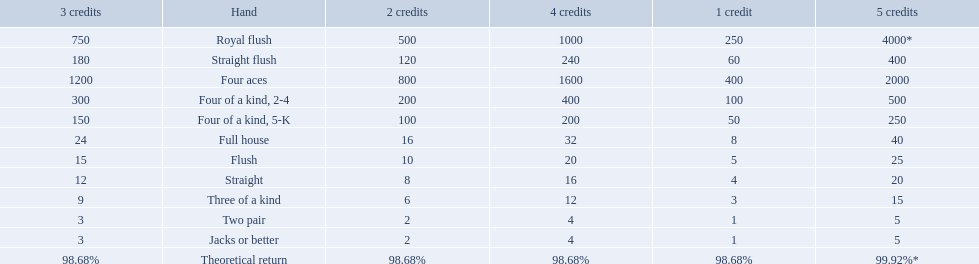What are the top 5 best types of hand for winning? Royal flush, Straight flush, Four aces, Four of a kind, 2-4, Four of a kind, 5-K. Between those 5, which of those hands are four of a kind? Four of a kind, 2-4, Four of a kind, 5-K. Of those 2 hands, which is the best kind of four of a kind for winning? Four of a kind, 2-4. 